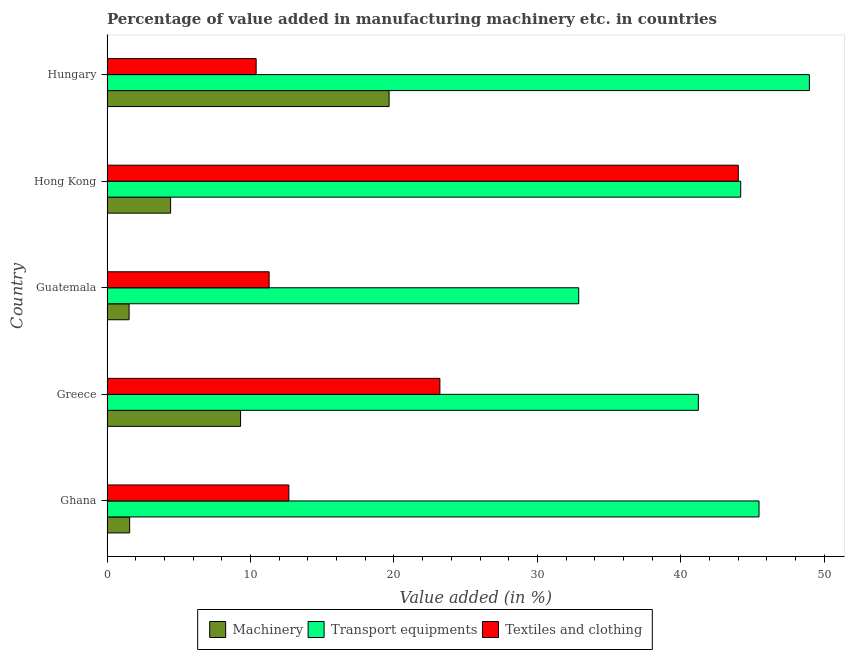How many groups of bars are there?
Offer a very short reply. 5. How many bars are there on the 4th tick from the top?
Offer a terse response. 3. What is the label of the 1st group of bars from the top?
Make the answer very short. Hungary. What is the value added in manufacturing transport equipments in Hungary?
Offer a terse response. 48.96. Across all countries, what is the maximum value added in manufacturing textile and clothing?
Your answer should be very brief. 44. Across all countries, what is the minimum value added in manufacturing transport equipments?
Provide a short and direct response. 32.88. In which country was the value added in manufacturing machinery maximum?
Make the answer very short. Hungary. In which country was the value added in manufacturing textile and clothing minimum?
Offer a very short reply. Hungary. What is the total value added in manufacturing textile and clothing in the graph?
Ensure brevity in your answer.  101.58. What is the difference between the value added in manufacturing machinery in Hong Kong and that in Hungary?
Give a very brief answer. -15.23. What is the difference between the value added in manufacturing textile and clothing in Hong Kong and the value added in manufacturing machinery in Greece?
Provide a succinct answer. 34.69. What is the average value added in manufacturing transport equipments per country?
Offer a very short reply. 42.54. What is the difference between the value added in manufacturing machinery and value added in manufacturing transport equipments in Hong Kong?
Provide a short and direct response. -39.74. In how many countries, is the value added in manufacturing textile and clothing greater than 36 %?
Your answer should be compact. 1. What is the ratio of the value added in manufacturing transport equipments in Ghana to that in Hong Kong?
Provide a short and direct response. 1.03. What is the difference between the highest and the second highest value added in manufacturing transport equipments?
Provide a succinct answer. 3.51. What is the difference between the highest and the lowest value added in manufacturing transport equipments?
Ensure brevity in your answer.  16.08. Is the sum of the value added in manufacturing textile and clothing in Ghana and Hungary greater than the maximum value added in manufacturing transport equipments across all countries?
Give a very brief answer. No. What does the 2nd bar from the top in Guatemala represents?
Your answer should be compact. Transport equipments. What does the 1st bar from the bottom in Hungary represents?
Keep it short and to the point. Machinery. Is it the case that in every country, the sum of the value added in manufacturing machinery and value added in manufacturing transport equipments is greater than the value added in manufacturing textile and clothing?
Your answer should be very brief. Yes. How many bars are there?
Your response must be concise. 15. How many countries are there in the graph?
Your response must be concise. 5. What is the difference between two consecutive major ticks on the X-axis?
Ensure brevity in your answer.  10. Does the graph contain any zero values?
Provide a short and direct response. No. Where does the legend appear in the graph?
Offer a very short reply. Bottom center. How many legend labels are there?
Keep it short and to the point. 3. How are the legend labels stacked?
Your answer should be compact. Horizontal. What is the title of the graph?
Your answer should be very brief. Percentage of value added in manufacturing machinery etc. in countries. What is the label or title of the X-axis?
Give a very brief answer. Value added (in %). What is the label or title of the Y-axis?
Provide a succinct answer. Country. What is the Value added (in %) in Machinery in Ghana?
Ensure brevity in your answer.  1.58. What is the Value added (in %) in Transport equipments in Ghana?
Offer a terse response. 45.45. What is the Value added (in %) in Textiles and clothing in Ghana?
Offer a terse response. 12.68. What is the Value added (in %) in Machinery in Greece?
Offer a very short reply. 9.31. What is the Value added (in %) in Transport equipments in Greece?
Your answer should be very brief. 41.22. What is the Value added (in %) of Textiles and clothing in Greece?
Provide a succinct answer. 23.2. What is the Value added (in %) of Machinery in Guatemala?
Your answer should be compact. 1.54. What is the Value added (in %) in Transport equipments in Guatemala?
Your answer should be very brief. 32.88. What is the Value added (in %) in Textiles and clothing in Guatemala?
Your answer should be very brief. 11.3. What is the Value added (in %) in Machinery in Hong Kong?
Offer a very short reply. 4.43. What is the Value added (in %) in Transport equipments in Hong Kong?
Your answer should be very brief. 44.17. What is the Value added (in %) in Textiles and clothing in Hong Kong?
Make the answer very short. 44. What is the Value added (in %) in Machinery in Hungary?
Provide a short and direct response. 19.66. What is the Value added (in %) of Transport equipments in Hungary?
Offer a terse response. 48.96. What is the Value added (in %) in Textiles and clothing in Hungary?
Provide a short and direct response. 10.4. Across all countries, what is the maximum Value added (in %) in Machinery?
Your answer should be very brief. 19.66. Across all countries, what is the maximum Value added (in %) in Transport equipments?
Provide a short and direct response. 48.96. Across all countries, what is the maximum Value added (in %) of Textiles and clothing?
Provide a short and direct response. 44. Across all countries, what is the minimum Value added (in %) in Machinery?
Your answer should be very brief. 1.54. Across all countries, what is the minimum Value added (in %) in Transport equipments?
Give a very brief answer. 32.88. Across all countries, what is the minimum Value added (in %) of Textiles and clothing?
Offer a very short reply. 10.4. What is the total Value added (in %) in Machinery in the graph?
Offer a very short reply. 36.53. What is the total Value added (in %) in Transport equipments in the graph?
Your answer should be compact. 212.68. What is the total Value added (in %) in Textiles and clothing in the graph?
Your answer should be very brief. 101.58. What is the difference between the Value added (in %) in Machinery in Ghana and that in Greece?
Offer a terse response. -7.73. What is the difference between the Value added (in %) in Transport equipments in Ghana and that in Greece?
Your response must be concise. 4.23. What is the difference between the Value added (in %) in Textiles and clothing in Ghana and that in Greece?
Your answer should be very brief. -10.53. What is the difference between the Value added (in %) of Machinery in Ghana and that in Guatemala?
Ensure brevity in your answer.  0.04. What is the difference between the Value added (in %) of Transport equipments in Ghana and that in Guatemala?
Keep it short and to the point. 12.57. What is the difference between the Value added (in %) of Textiles and clothing in Ghana and that in Guatemala?
Your answer should be very brief. 1.37. What is the difference between the Value added (in %) of Machinery in Ghana and that in Hong Kong?
Your answer should be very brief. -2.85. What is the difference between the Value added (in %) in Transport equipments in Ghana and that in Hong Kong?
Make the answer very short. 1.28. What is the difference between the Value added (in %) in Textiles and clothing in Ghana and that in Hong Kong?
Give a very brief answer. -31.33. What is the difference between the Value added (in %) of Machinery in Ghana and that in Hungary?
Keep it short and to the point. -18.08. What is the difference between the Value added (in %) of Transport equipments in Ghana and that in Hungary?
Keep it short and to the point. -3.51. What is the difference between the Value added (in %) in Textiles and clothing in Ghana and that in Hungary?
Provide a succinct answer. 2.28. What is the difference between the Value added (in %) of Machinery in Greece and that in Guatemala?
Provide a succinct answer. 7.77. What is the difference between the Value added (in %) in Transport equipments in Greece and that in Guatemala?
Provide a succinct answer. 8.34. What is the difference between the Value added (in %) in Textiles and clothing in Greece and that in Guatemala?
Provide a succinct answer. 11.9. What is the difference between the Value added (in %) of Machinery in Greece and that in Hong Kong?
Keep it short and to the point. 4.88. What is the difference between the Value added (in %) of Transport equipments in Greece and that in Hong Kong?
Give a very brief answer. -2.95. What is the difference between the Value added (in %) of Textiles and clothing in Greece and that in Hong Kong?
Offer a terse response. -20.8. What is the difference between the Value added (in %) of Machinery in Greece and that in Hungary?
Offer a very short reply. -10.35. What is the difference between the Value added (in %) in Transport equipments in Greece and that in Hungary?
Your answer should be very brief. -7.74. What is the difference between the Value added (in %) in Textiles and clothing in Greece and that in Hungary?
Your answer should be compact. 12.81. What is the difference between the Value added (in %) of Machinery in Guatemala and that in Hong Kong?
Provide a short and direct response. -2.89. What is the difference between the Value added (in %) of Transport equipments in Guatemala and that in Hong Kong?
Offer a terse response. -11.29. What is the difference between the Value added (in %) in Textiles and clothing in Guatemala and that in Hong Kong?
Provide a succinct answer. -32.7. What is the difference between the Value added (in %) of Machinery in Guatemala and that in Hungary?
Ensure brevity in your answer.  -18.12. What is the difference between the Value added (in %) in Transport equipments in Guatemala and that in Hungary?
Give a very brief answer. -16.08. What is the difference between the Value added (in %) in Textiles and clothing in Guatemala and that in Hungary?
Provide a succinct answer. 0.9. What is the difference between the Value added (in %) in Machinery in Hong Kong and that in Hungary?
Ensure brevity in your answer.  -15.23. What is the difference between the Value added (in %) in Transport equipments in Hong Kong and that in Hungary?
Give a very brief answer. -4.79. What is the difference between the Value added (in %) of Textiles and clothing in Hong Kong and that in Hungary?
Your answer should be compact. 33.61. What is the difference between the Value added (in %) of Machinery in Ghana and the Value added (in %) of Transport equipments in Greece?
Your answer should be compact. -39.64. What is the difference between the Value added (in %) of Machinery in Ghana and the Value added (in %) of Textiles and clothing in Greece?
Provide a short and direct response. -21.63. What is the difference between the Value added (in %) of Transport equipments in Ghana and the Value added (in %) of Textiles and clothing in Greece?
Provide a short and direct response. 22.24. What is the difference between the Value added (in %) in Machinery in Ghana and the Value added (in %) in Transport equipments in Guatemala?
Provide a succinct answer. -31.3. What is the difference between the Value added (in %) in Machinery in Ghana and the Value added (in %) in Textiles and clothing in Guatemala?
Your answer should be very brief. -9.72. What is the difference between the Value added (in %) in Transport equipments in Ghana and the Value added (in %) in Textiles and clothing in Guatemala?
Give a very brief answer. 34.15. What is the difference between the Value added (in %) in Machinery in Ghana and the Value added (in %) in Transport equipments in Hong Kong?
Your response must be concise. -42.59. What is the difference between the Value added (in %) in Machinery in Ghana and the Value added (in %) in Textiles and clothing in Hong Kong?
Ensure brevity in your answer.  -42.42. What is the difference between the Value added (in %) of Transport equipments in Ghana and the Value added (in %) of Textiles and clothing in Hong Kong?
Your answer should be very brief. 1.45. What is the difference between the Value added (in %) of Machinery in Ghana and the Value added (in %) of Transport equipments in Hungary?
Offer a terse response. -47.38. What is the difference between the Value added (in %) of Machinery in Ghana and the Value added (in %) of Textiles and clothing in Hungary?
Your answer should be very brief. -8.82. What is the difference between the Value added (in %) in Transport equipments in Ghana and the Value added (in %) in Textiles and clothing in Hungary?
Give a very brief answer. 35.05. What is the difference between the Value added (in %) of Machinery in Greece and the Value added (in %) of Transport equipments in Guatemala?
Ensure brevity in your answer.  -23.57. What is the difference between the Value added (in %) in Machinery in Greece and the Value added (in %) in Textiles and clothing in Guatemala?
Offer a terse response. -1.99. What is the difference between the Value added (in %) in Transport equipments in Greece and the Value added (in %) in Textiles and clothing in Guatemala?
Your answer should be compact. 29.92. What is the difference between the Value added (in %) in Machinery in Greece and the Value added (in %) in Transport equipments in Hong Kong?
Provide a succinct answer. -34.86. What is the difference between the Value added (in %) of Machinery in Greece and the Value added (in %) of Textiles and clothing in Hong Kong?
Make the answer very short. -34.69. What is the difference between the Value added (in %) in Transport equipments in Greece and the Value added (in %) in Textiles and clothing in Hong Kong?
Offer a very short reply. -2.78. What is the difference between the Value added (in %) in Machinery in Greece and the Value added (in %) in Transport equipments in Hungary?
Your answer should be compact. -39.65. What is the difference between the Value added (in %) of Machinery in Greece and the Value added (in %) of Textiles and clothing in Hungary?
Provide a succinct answer. -1.09. What is the difference between the Value added (in %) in Transport equipments in Greece and the Value added (in %) in Textiles and clothing in Hungary?
Offer a terse response. 30.82. What is the difference between the Value added (in %) in Machinery in Guatemala and the Value added (in %) in Transport equipments in Hong Kong?
Your answer should be compact. -42.63. What is the difference between the Value added (in %) of Machinery in Guatemala and the Value added (in %) of Textiles and clothing in Hong Kong?
Offer a terse response. -42.46. What is the difference between the Value added (in %) in Transport equipments in Guatemala and the Value added (in %) in Textiles and clothing in Hong Kong?
Keep it short and to the point. -11.12. What is the difference between the Value added (in %) in Machinery in Guatemala and the Value added (in %) in Transport equipments in Hungary?
Provide a short and direct response. -47.42. What is the difference between the Value added (in %) in Machinery in Guatemala and the Value added (in %) in Textiles and clothing in Hungary?
Offer a terse response. -8.86. What is the difference between the Value added (in %) of Transport equipments in Guatemala and the Value added (in %) of Textiles and clothing in Hungary?
Make the answer very short. 22.49. What is the difference between the Value added (in %) of Machinery in Hong Kong and the Value added (in %) of Transport equipments in Hungary?
Make the answer very short. -44.53. What is the difference between the Value added (in %) in Machinery in Hong Kong and the Value added (in %) in Textiles and clothing in Hungary?
Provide a succinct answer. -5.96. What is the difference between the Value added (in %) of Transport equipments in Hong Kong and the Value added (in %) of Textiles and clothing in Hungary?
Provide a succinct answer. 33.77. What is the average Value added (in %) in Machinery per country?
Make the answer very short. 7.31. What is the average Value added (in %) in Transport equipments per country?
Your answer should be very brief. 42.54. What is the average Value added (in %) of Textiles and clothing per country?
Give a very brief answer. 20.32. What is the difference between the Value added (in %) in Machinery and Value added (in %) in Transport equipments in Ghana?
Make the answer very short. -43.87. What is the difference between the Value added (in %) in Machinery and Value added (in %) in Textiles and clothing in Ghana?
Keep it short and to the point. -11.1. What is the difference between the Value added (in %) of Transport equipments and Value added (in %) of Textiles and clothing in Ghana?
Offer a very short reply. 32.77. What is the difference between the Value added (in %) of Machinery and Value added (in %) of Transport equipments in Greece?
Ensure brevity in your answer.  -31.91. What is the difference between the Value added (in %) in Machinery and Value added (in %) in Textiles and clothing in Greece?
Provide a succinct answer. -13.89. What is the difference between the Value added (in %) in Transport equipments and Value added (in %) in Textiles and clothing in Greece?
Offer a very short reply. 18.02. What is the difference between the Value added (in %) in Machinery and Value added (in %) in Transport equipments in Guatemala?
Make the answer very short. -31.34. What is the difference between the Value added (in %) in Machinery and Value added (in %) in Textiles and clothing in Guatemala?
Your answer should be very brief. -9.76. What is the difference between the Value added (in %) of Transport equipments and Value added (in %) of Textiles and clothing in Guatemala?
Keep it short and to the point. 21.58. What is the difference between the Value added (in %) of Machinery and Value added (in %) of Transport equipments in Hong Kong?
Your answer should be very brief. -39.74. What is the difference between the Value added (in %) in Machinery and Value added (in %) in Textiles and clothing in Hong Kong?
Provide a short and direct response. -39.57. What is the difference between the Value added (in %) of Transport equipments and Value added (in %) of Textiles and clothing in Hong Kong?
Offer a terse response. 0.17. What is the difference between the Value added (in %) in Machinery and Value added (in %) in Transport equipments in Hungary?
Your answer should be very brief. -29.3. What is the difference between the Value added (in %) of Machinery and Value added (in %) of Textiles and clothing in Hungary?
Make the answer very short. 9.27. What is the difference between the Value added (in %) of Transport equipments and Value added (in %) of Textiles and clothing in Hungary?
Make the answer very short. 38.56. What is the ratio of the Value added (in %) of Machinery in Ghana to that in Greece?
Offer a terse response. 0.17. What is the ratio of the Value added (in %) in Transport equipments in Ghana to that in Greece?
Provide a succinct answer. 1.1. What is the ratio of the Value added (in %) of Textiles and clothing in Ghana to that in Greece?
Keep it short and to the point. 0.55. What is the ratio of the Value added (in %) in Machinery in Ghana to that in Guatemala?
Your answer should be compact. 1.02. What is the ratio of the Value added (in %) in Transport equipments in Ghana to that in Guatemala?
Provide a succinct answer. 1.38. What is the ratio of the Value added (in %) of Textiles and clothing in Ghana to that in Guatemala?
Your answer should be very brief. 1.12. What is the ratio of the Value added (in %) of Machinery in Ghana to that in Hong Kong?
Ensure brevity in your answer.  0.36. What is the ratio of the Value added (in %) of Transport equipments in Ghana to that in Hong Kong?
Give a very brief answer. 1.03. What is the ratio of the Value added (in %) in Textiles and clothing in Ghana to that in Hong Kong?
Provide a short and direct response. 0.29. What is the ratio of the Value added (in %) of Machinery in Ghana to that in Hungary?
Provide a succinct answer. 0.08. What is the ratio of the Value added (in %) of Transport equipments in Ghana to that in Hungary?
Give a very brief answer. 0.93. What is the ratio of the Value added (in %) in Textiles and clothing in Ghana to that in Hungary?
Make the answer very short. 1.22. What is the ratio of the Value added (in %) in Machinery in Greece to that in Guatemala?
Your answer should be very brief. 6.04. What is the ratio of the Value added (in %) of Transport equipments in Greece to that in Guatemala?
Keep it short and to the point. 1.25. What is the ratio of the Value added (in %) of Textiles and clothing in Greece to that in Guatemala?
Your response must be concise. 2.05. What is the ratio of the Value added (in %) in Machinery in Greece to that in Hong Kong?
Your answer should be very brief. 2.1. What is the ratio of the Value added (in %) in Transport equipments in Greece to that in Hong Kong?
Offer a very short reply. 0.93. What is the ratio of the Value added (in %) of Textiles and clothing in Greece to that in Hong Kong?
Your answer should be compact. 0.53. What is the ratio of the Value added (in %) in Machinery in Greece to that in Hungary?
Ensure brevity in your answer.  0.47. What is the ratio of the Value added (in %) in Transport equipments in Greece to that in Hungary?
Make the answer very short. 0.84. What is the ratio of the Value added (in %) in Textiles and clothing in Greece to that in Hungary?
Give a very brief answer. 2.23. What is the ratio of the Value added (in %) of Machinery in Guatemala to that in Hong Kong?
Keep it short and to the point. 0.35. What is the ratio of the Value added (in %) of Transport equipments in Guatemala to that in Hong Kong?
Offer a terse response. 0.74. What is the ratio of the Value added (in %) of Textiles and clothing in Guatemala to that in Hong Kong?
Give a very brief answer. 0.26. What is the ratio of the Value added (in %) in Machinery in Guatemala to that in Hungary?
Your response must be concise. 0.08. What is the ratio of the Value added (in %) of Transport equipments in Guatemala to that in Hungary?
Provide a succinct answer. 0.67. What is the ratio of the Value added (in %) in Textiles and clothing in Guatemala to that in Hungary?
Provide a short and direct response. 1.09. What is the ratio of the Value added (in %) of Machinery in Hong Kong to that in Hungary?
Give a very brief answer. 0.23. What is the ratio of the Value added (in %) in Transport equipments in Hong Kong to that in Hungary?
Make the answer very short. 0.9. What is the ratio of the Value added (in %) in Textiles and clothing in Hong Kong to that in Hungary?
Provide a succinct answer. 4.23. What is the difference between the highest and the second highest Value added (in %) of Machinery?
Provide a succinct answer. 10.35. What is the difference between the highest and the second highest Value added (in %) of Transport equipments?
Provide a succinct answer. 3.51. What is the difference between the highest and the second highest Value added (in %) of Textiles and clothing?
Your answer should be very brief. 20.8. What is the difference between the highest and the lowest Value added (in %) of Machinery?
Keep it short and to the point. 18.12. What is the difference between the highest and the lowest Value added (in %) in Transport equipments?
Make the answer very short. 16.08. What is the difference between the highest and the lowest Value added (in %) of Textiles and clothing?
Your answer should be very brief. 33.61. 